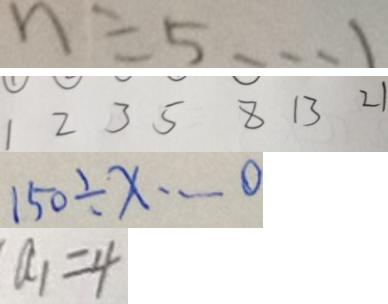<formula> <loc_0><loc_0><loc_500><loc_500>n \div 5 \cdots 1 
 1 2 3 5 8 1 3 2 1 
 1 5 0 \div x \cdots 0 
 a _ { 1 } = 4</formula> 